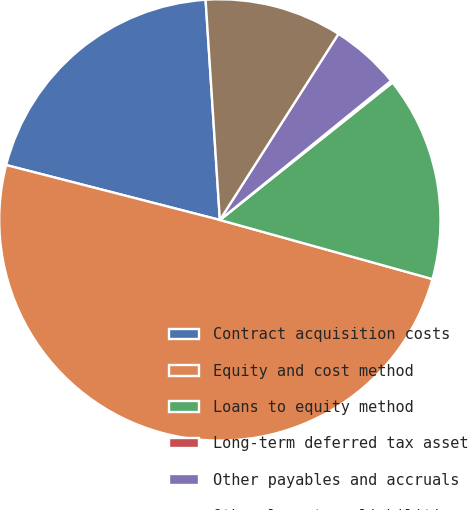Convert chart. <chart><loc_0><loc_0><loc_500><loc_500><pie_chart><fcel>Contract acquisition costs<fcel>Equity and cost method<fcel>Loans to equity method<fcel>Long-term deferred tax asset<fcel>Other payables and accruals<fcel>Other long-term liabilities<nl><fcel>19.97%<fcel>49.69%<fcel>15.02%<fcel>0.16%<fcel>5.11%<fcel>10.06%<nl></chart> 